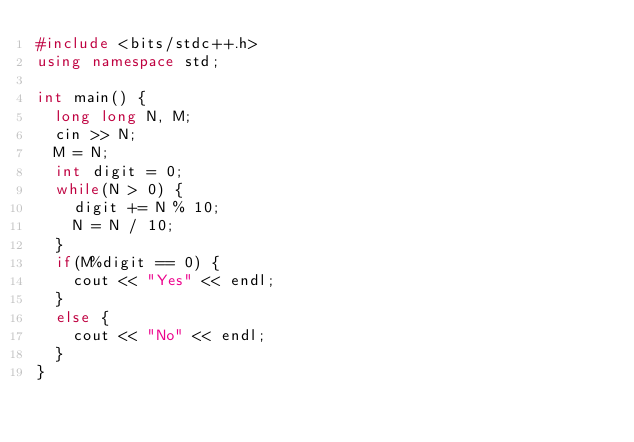Convert code to text. <code><loc_0><loc_0><loc_500><loc_500><_C++_>#include <bits/stdc++.h>
using namespace std;

int main() {
  long long N, M;
  cin >> N;
  M = N;
  int digit = 0;
  while(N > 0) {
    digit += N % 10;
    N = N / 10;
  }
  if(M%digit == 0) {
    cout << "Yes" << endl;
  }
  else {
    cout << "No" << endl;
  }
}
</code> 